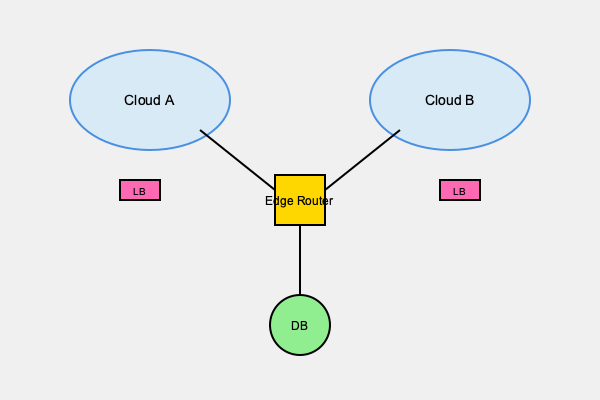In the given cloud computing infrastructure diagram, what is the primary purpose of the Edge Router, and how does it contribute to the overall system architecture? To answer this question, let's analyze the diagram step-by-step:

1. Network topology: The diagram shows two cloud environments (Cloud A and Cloud B) connected to a central Edge Router.

2. Edge Router position: The Edge Router is located between the two cloud environments and the database (DB).

3. Connections:
   a. Both Cloud A and Cloud B have direct connections to the Edge Router.
   b. The Edge Router has a direct connection to the database.

4. Load Balancers (LB): Each cloud environment has its own load balancer.

5. Edge Router function:
   a. Interconnection: It serves as a central point of interconnection between different network segments (Cloud A, Cloud B, and the database).
   b. Traffic management: It likely manages and routes traffic between the clouds and the database.
   c. Security: As a boundary device, it can enforce security policies and act as a firewall.
   d. Protocol translation: It may perform protocol translation if the clouds and database use different networking protocols.

6. System architecture contribution:
   a. Centralized control: Provides a single point for managing inter-cloud and cloud-to-database communications.
   b. Scalability: Allows for easy addition of new cloud environments or resources.
   c. Performance optimization: Can make intelligent routing decisions to optimize network performance.
   d. Isolation: Helps maintain logical separation between different cloud environments while allowing controlled communication.

Given these observations, the primary purpose of the Edge Router is to facilitate and control communication between multiple cloud environments and the central database, while contributing to the overall system architecture by providing centralized management, scalability, performance optimization, and network segmentation.
Answer: Facilitate inter-cloud communication and database access; provide centralized traffic management and security control. 